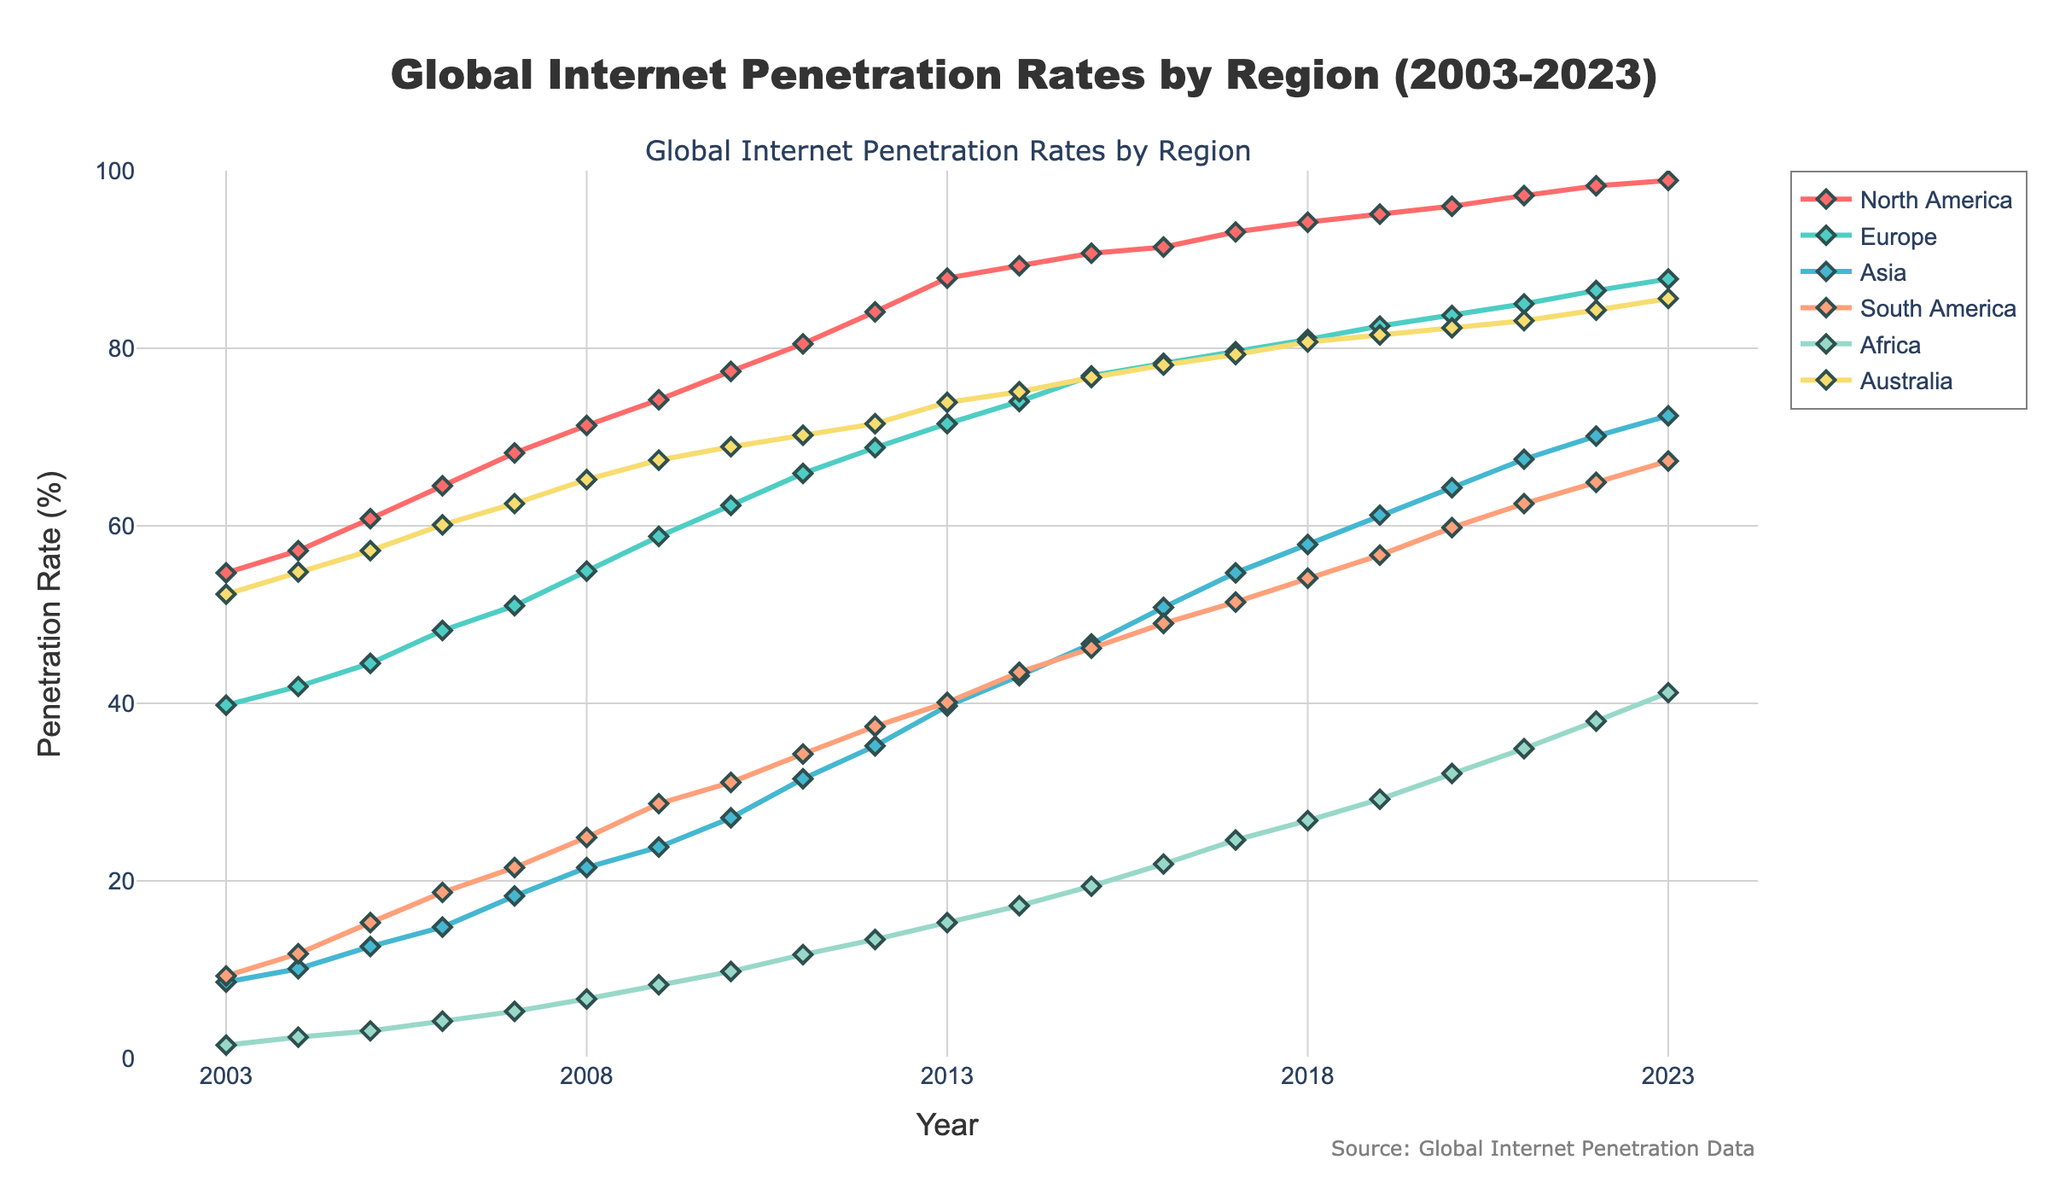What's the title of the figure? The title of the figure is displayed prominently at the top of the plot in larger and bold text.
Answer: Global Internet Penetration Rates by Region (2003-2023) Which region had the highest internet penetration in 2023? To determine this, look at the rightmost data points on the lines and identify which line ends at the highest value on the y-axis.
Answer: North America By how many percentage points did Africa's internet penetration rate increase from 2003 to 2023? Subtract Africa's percentage in 2003 (1.5%) from its percentage in 2023 (41.2%) to find the increase.
Answer: 39.7 Which region had the largest increase in internet penetration rate from 2003 to 2023? Compare the difference in internet penetration rates from 2003 to 2023 for each region. The region with the highest difference had the largest increase.
Answer: Asia What is the average internet penetration rate in Europe over the period 2003-2023? Sum all the internet penetration rates for Europe from 2003 to 2023 and divide by the number of years (21). Calculation: (39.8+41.9+44.5+48.2+51+54.9+58.8+62.3+65.9+68.8+71.5+74+76.9+78.3+79.6+81+82.5+83.7+85+86.5+87.8)/21.
Answer: 68.3 How does the trend of internet penetration rates in North America compare to Africa? Observe the slope and shape of the lines representing North America and Africa. North America starts at a high penetration rate and gradually increases, while Africa starts low and increases more steeply over time.
Answer: North America grows steadily; Africa grows steeply In which year did South America’s internet penetration rate surpass 50%? Look for the point at which South America's line crosses the 50% mark on the y-axis.
Answer: 2017 Which regions show a relatively linear growth in internet penetration rates? Identify the regions with lines that appear straight and evenly spaced between data points.
Answer: North America, Europe, Australia What was the internet penetration growth rate in Asia from 2010 to 2015, and how does it compare to the growth rate in Australia during the same period? Calculate the growth for each region by subtracting the 2010 value from the 2015 value for Asia and Australia, then compare the two results. Asia: 46.7-27.1=19.6%. Australia: 76.7-68.9=7.8%.
Answer: Asia: 19.6%, Australia: 7.8%, Asia had a higher growth rate 